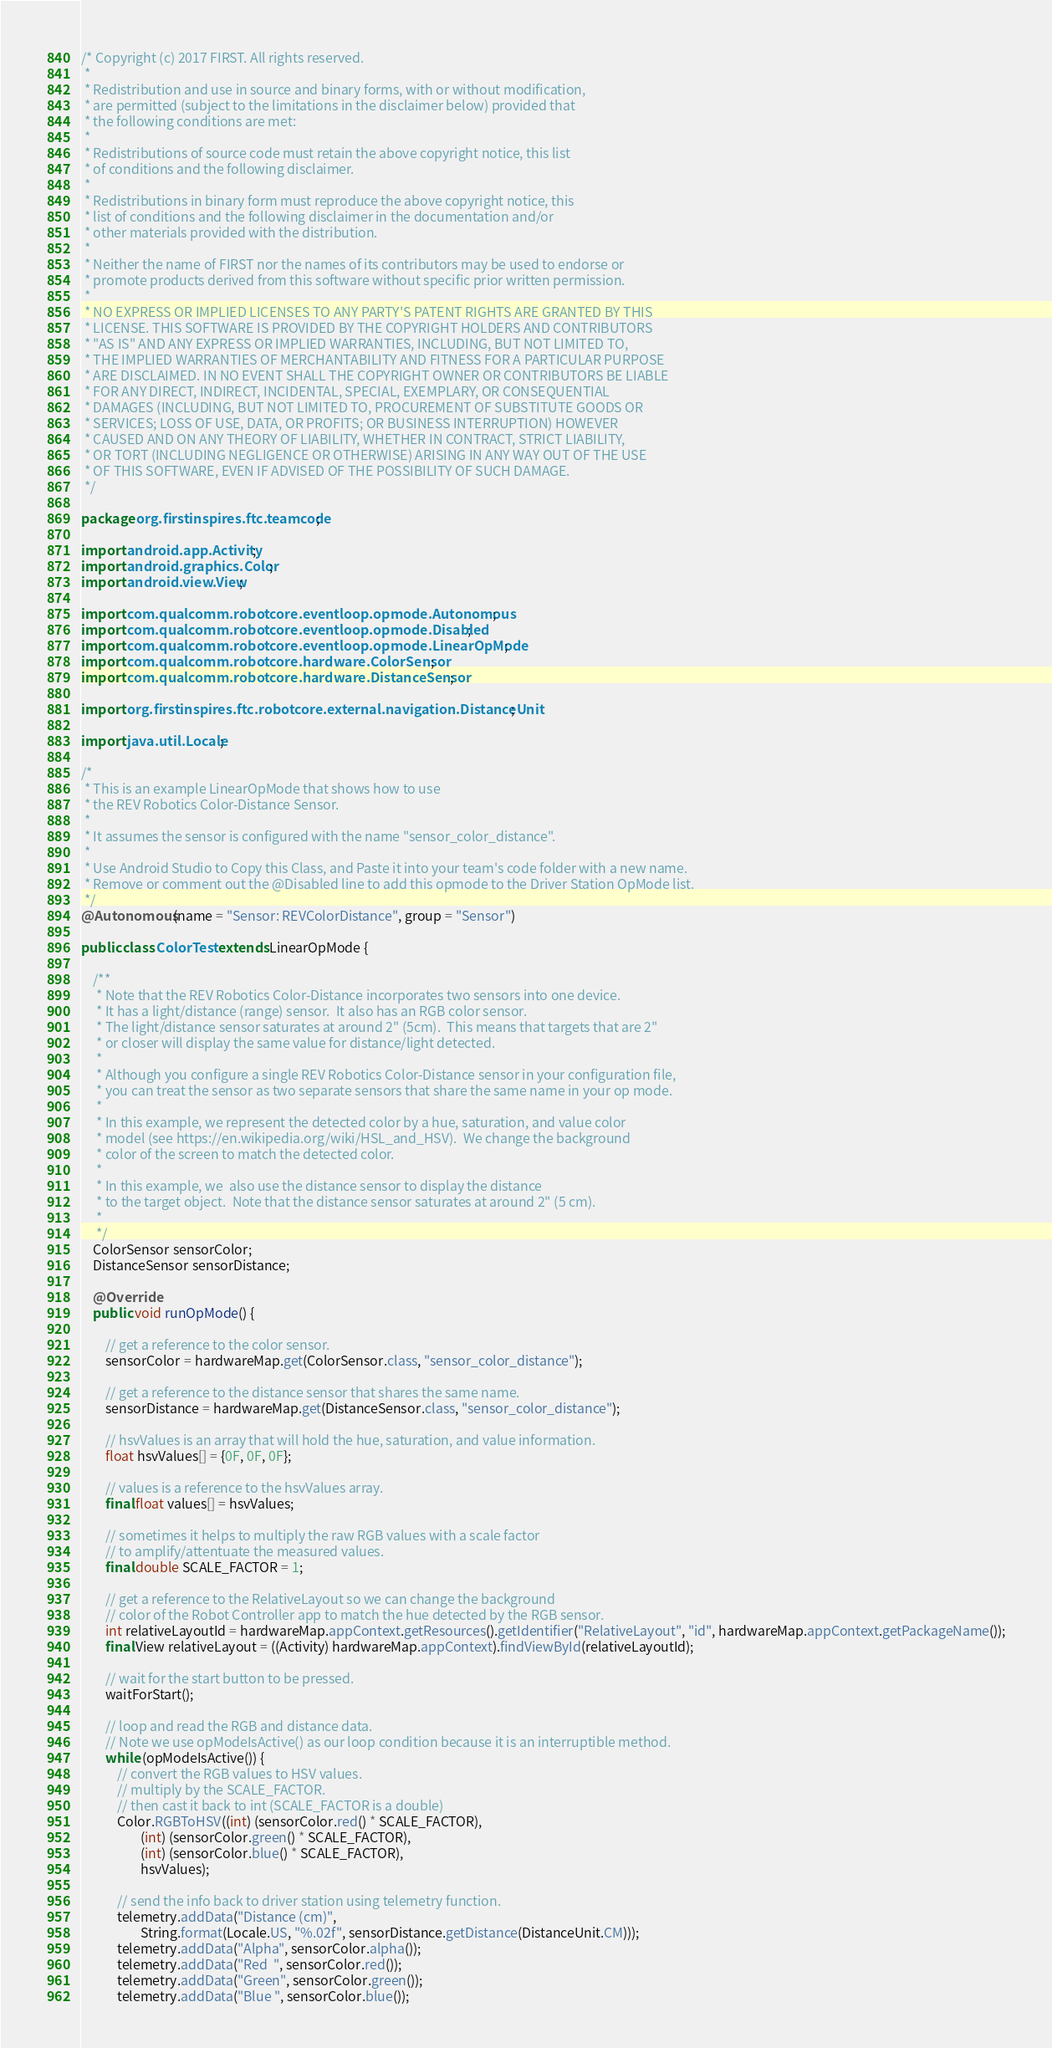<code> <loc_0><loc_0><loc_500><loc_500><_Java_>/* Copyright (c) 2017 FIRST. All rights reserved.
 *
 * Redistribution and use in source and binary forms, with or without modification,
 * are permitted (subject to the limitations in the disclaimer below) provided that
 * the following conditions are met:
 *
 * Redistributions of source code must retain the above copyright notice, this list
 * of conditions and the following disclaimer.
 *
 * Redistributions in binary form must reproduce the above copyright notice, this
 * list of conditions and the following disclaimer in the documentation and/or
 * other materials provided with the distribution.
 *
 * Neither the name of FIRST nor the names of its contributors may be used to endorse or
 * promote products derived from this software without specific prior written permission.
 *
 * NO EXPRESS OR IMPLIED LICENSES TO ANY PARTY'S PATENT RIGHTS ARE GRANTED BY THIS
 * LICENSE. THIS SOFTWARE IS PROVIDED BY THE COPYRIGHT HOLDERS AND CONTRIBUTORS
 * "AS IS" AND ANY EXPRESS OR IMPLIED WARRANTIES, INCLUDING, BUT NOT LIMITED TO,
 * THE IMPLIED WARRANTIES OF MERCHANTABILITY AND FITNESS FOR A PARTICULAR PURPOSE
 * ARE DISCLAIMED. IN NO EVENT SHALL THE COPYRIGHT OWNER OR CONTRIBUTORS BE LIABLE
 * FOR ANY DIRECT, INDIRECT, INCIDENTAL, SPECIAL, EXEMPLARY, OR CONSEQUENTIAL
 * DAMAGES (INCLUDING, BUT NOT LIMITED TO, PROCUREMENT OF SUBSTITUTE GOODS OR
 * SERVICES; LOSS OF USE, DATA, OR PROFITS; OR BUSINESS INTERRUPTION) HOWEVER
 * CAUSED AND ON ANY THEORY OF LIABILITY, WHETHER IN CONTRACT, STRICT LIABILITY,
 * OR TORT (INCLUDING NEGLIGENCE OR OTHERWISE) ARISING IN ANY WAY OUT OF THE USE
 * OF THIS SOFTWARE, EVEN IF ADVISED OF THE POSSIBILITY OF SUCH DAMAGE.
 */

package org.firstinspires.ftc.teamcode;

import android.app.Activity;
import android.graphics.Color;
import android.view.View;

import com.qualcomm.robotcore.eventloop.opmode.Autonomous;
import com.qualcomm.robotcore.eventloop.opmode.Disabled;
import com.qualcomm.robotcore.eventloop.opmode.LinearOpMode;
import com.qualcomm.robotcore.hardware.ColorSensor;
import com.qualcomm.robotcore.hardware.DistanceSensor;

import org.firstinspires.ftc.robotcore.external.navigation.DistanceUnit;

import java.util.Locale;

/*
 * This is an example LinearOpMode that shows how to use
 * the REV Robotics Color-Distance Sensor.
 *
 * It assumes the sensor is configured with the name "sensor_color_distance".
 *
 * Use Android Studio to Copy this Class, and Paste it into your team's code folder with a new name.
 * Remove or comment out the @Disabled line to add this opmode to the Driver Station OpMode list.
 */
@Autonomous(name = "Sensor: REVColorDistance", group = "Sensor")

public class ColorTest extends LinearOpMode {

    /**
     * Note that the REV Robotics Color-Distance incorporates two sensors into one device.
     * It has a light/distance (range) sensor.  It also has an RGB color sensor.
     * The light/distance sensor saturates at around 2" (5cm).  This means that targets that are 2"
     * or closer will display the same value for distance/light detected.
     *
     * Although you configure a single REV Robotics Color-Distance sensor in your configuration file,
     * you can treat the sensor as two separate sensors that share the same name in your op mode.
     *
     * In this example, we represent the detected color by a hue, saturation, and value color
     * model (see https://en.wikipedia.org/wiki/HSL_and_HSV).  We change the background
     * color of the screen to match the detected color.
     *
     * In this example, we  also use the distance sensor to display the distance
     * to the target object.  Note that the distance sensor saturates at around 2" (5 cm).
     *
     */
    ColorSensor sensorColor;
    DistanceSensor sensorDistance;

    @Override
    public void runOpMode() {

        // get a reference to the color sensor.
        sensorColor = hardwareMap.get(ColorSensor.class, "sensor_color_distance");

        // get a reference to the distance sensor that shares the same name.
        sensorDistance = hardwareMap.get(DistanceSensor.class, "sensor_color_distance");

        // hsvValues is an array that will hold the hue, saturation, and value information.
        float hsvValues[] = {0F, 0F, 0F};

        // values is a reference to the hsvValues array.
        final float values[] = hsvValues;

        // sometimes it helps to multiply the raw RGB values with a scale factor
        // to amplify/attentuate the measured values.
        final double SCALE_FACTOR = 1;

        // get a reference to the RelativeLayout so we can change the background
        // color of the Robot Controller app to match the hue detected by the RGB sensor.
        int relativeLayoutId = hardwareMap.appContext.getResources().getIdentifier("RelativeLayout", "id", hardwareMap.appContext.getPackageName());
        final View relativeLayout = ((Activity) hardwareMap.appContext).findViewById(relativeLayoutId);

        // wait for the start button to be pressed.
        waitForStart();

        // loop and read the RGB and distance data.
        // Note we use opModeIsActive() as our loop condition because it is an interruptible method.
        while (opModeIsActive()) {
            // convert the RGB values to HSV values.
            // multiply by the SCALE_FACTOR.
            // then cast it back to int (SCALE_FACTOR is a double)
            Color.RGBToHSV((int) (sensorColor.red() * SCALE_FACTOR),
                    (int) (sensorColor.green() * SCALE_FACTOR),
                    (int) (sensorColor.blue() * SCALE_FACTOR),
                    hsvValues);

            // send the info back to driver station using telemetry function.
            telemetry.addData("Distance (cm)",
                    String.format(Locale.US, "%.02f", sensorDistance.getDistance(DistanceUnit.CM)));
            telemetry.addData("Alpha", sensorColor.alpha());
            telemetry.addData("Red  ", sensorColor.red());
            telemetry.addData("Green", sensorColor.green());
            telemetry.addData("Blue ", sensorColor.blue());</code> 